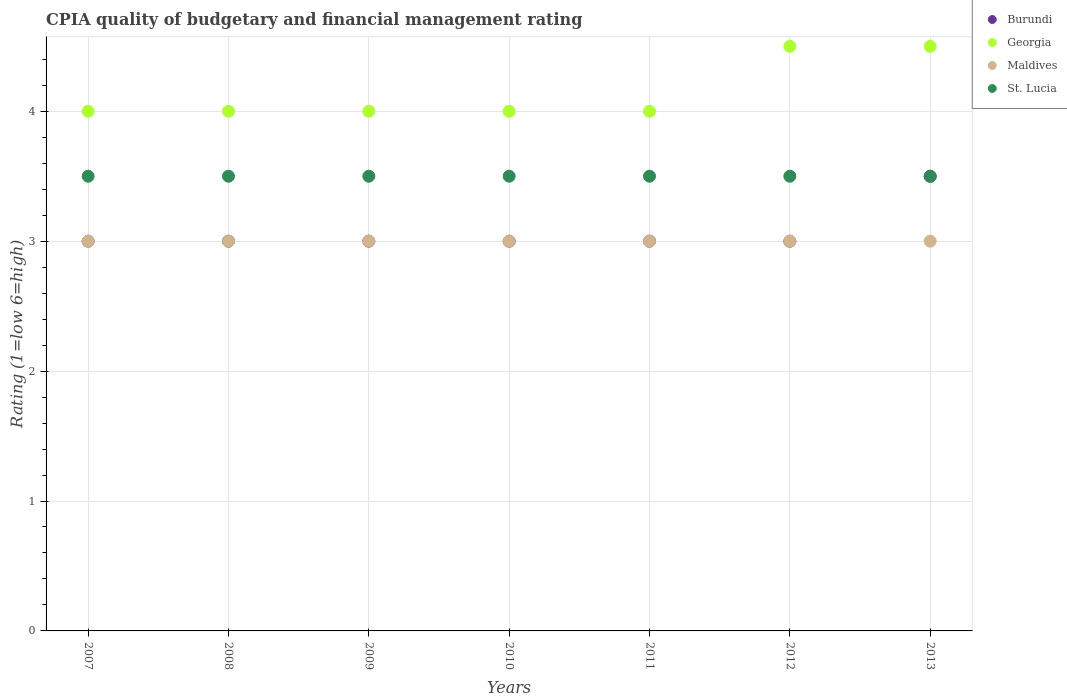Across all years, what is the minimum CPIA rating in Maldives?
Your answer should be compact. 3. In which year was the CPIA rating in St. Lucia maximum?
Ensure brevity in your answer.  2007. In which year was the CPIA rating in St. Lucia minimum?
Your response must be concise. 2007. What is the average CPIA rating in St. Lucia per year?
Offer a terse response. 3.5. In the year 2007, what is the difference between the CPIA rating in Maldives and CPIA rating in St. Lucia?
Offer a very short reply. -0.5. What is the ratio of the CPIA rating in Georgia in 2007 to that in 2013?
Make the answer very short. 0.89. In how many years, is the CPIA rating in Georgia greater than the average CPIA rating in Georgia taken over all years?
Your answer should be compact. 2. Is it the case that in every year, the sum of the CPIA rating in Burundi and CPIA rating in Maldives  is greater than the sum of CPIA rating in St. Lucia and CPIA rating in Georgia?
Your answer should be very brief. No. Is it the case that in every year, the sum of the CPIA rating in Georgia and CPIA rating in St. Lucia  is greater than the CPIA rating in Maldives?
Your response must be concise. Yes. Does the CPIA rating in Maldives monotonically increase over the years?
Provide a succinct answer. No. Is the CPIA rating in St. Lucia strictly greater than the CPIA rating in Georgia over the years?
Your answer should be compact. No. How many dotlines are there?
Provide a succinct answer. 4. How many years are there in the graph?
Your answer should be compact. 7. What is the difference between two consecutive major ticks on the Y-axis?
Give a very brief answer. 1. Are the values on the major ticks of Y-axis written in scientific E-notation?
Give a very brief answer. No. Does the graph contain grids?
Make the answer very short. Yes. Where does the legend appear in the graph?
Your answer should be very brief. Top right. What is the title of the graph?
Keep it short and to the point. CPIA quality of budgetary and financial management rating. What is the label or title of the X-axis?
Provide a succinct answer. Years. What is the Rating (1=low 6=high) in Burundi in 2007?
Your response must be concise. 3. What is the Rating (1=low 6=high) in Georgia in 2007?
Provide a succinct answer. 4. What is the Rating (1=low 6=high) in Maldives in 2007?
Offer a very short reply. 3. What is the Rating (1=low 6=high) in St. Lucia in 2007?
Your answer should be compact. 3.5. What is the Rating (1=low 6=high) in Georgia in 2008?
Offer a very short reply. 4. What is the Rating (1=low 6=high) of St. Lucia in 2008?
Provide a succinct answer. 3.5. What is the Rating (1=low 6=high) of Maldives in 2009?
Ensure brevity in your answer.  3. What is the Rating (1=low 6=high) of St. Lucia in 2009?
Ensure brevity in your answer.  3.5. What is the Rating (1=low 6=high) of Burundi in 2010?
Ensure brevity in your answer.  3. What is the Rating (1=low 6=high) in Georgia in 2010?
Offer a very short reply. 4. What is the Rating (1=low 6=high) in Georgia in 2011?
Provide a succinct answer. 4. What is the Rating (1=low 6=high) of Georgia in 2013?
Keep it short and to the point. 4.5. What is the Rating (1=low 6=high) of St. Lucia in 2013?
Your response must be concise. 3.5. Across all years, what is the maximum Rating (1=low 6=high) in Burundi?
Your answer should be very brief. 3.5. Across all years, what is the maximum Rating (1=low 6=high) in Georgia?
Ensure brevity in your answer.  4.5. Across all years, what is the maximum Rating (1=low 6=high) in St. Lucia?
Give a very brief answer. 3.5. Across all years, what is the minimum Rating (1=low 6=high) in Georgia?
Give a very brief answer. 4. Across all years, what is the minimum Rating (1=low 6=high) of Maldives?
Provide a succinct answer. 3. Across all years, what is the minimum Rating (1=low 6=high) in St. Lucia?
Offer a terse response. 3.5. What is the total Rating (1=low 6=high) of Maldives in the graph?
Your answer should be very brief. 21. What is the difference between the Rating (1=low 6=high) of Burundi in 2007 and that in 2008?
Your response must be concise. 0. What is the difference between the Rating (1=low 6=high) of St. Lucia in 2007 and that in 2008?
Provide a short and direct response. 0. What is the difference between the Rating (1=low 6=high) in Maldives in 2007 and that in 2009?
Your answer should be compact. 0. What is the difference between the Rating (1=low 6=high) in St. Lucia in 2007 and that in 2009?
Provide a short and direct response. 0. What is the difference between the Rating (1=low 6=high) of Burundi in 2007 and that in 2010?
Keep it short and to the point. 0. What is the difference between the Rating (1=low 6=high) of Georgia in 2007 and that in 2010?
Give a very brief answer. 0. What is the difference between the Rating (1=low 6=high) of St. Lucia in 2007 and that in 2010?
Keep it short and to the point. 0. What is the difference between the Rating (1=low 6=high) in Maldives in 2007 and that in 2011?
Keep it short and to the point. 0. What is the difference between the Rating (1=low 6=high) of St. Lucia in 2007 and that in 2011?
Provide a succinct answer. 0. What is the difference between the Rating (1=low 6=high) in Georgia in 2007 and that in 2012?
Ensure brevity in your answer.  -0.5. What is the difference between the Rating (1=low 6=high) in Maldives in 2007 and that in 2012?
Provide a short and direct response. 0. What is the difference between the Rating (1=low 6=high) of Burundi in 2007 and that in 2013?
Your answer should be compact. -0.5. What is the difference between the Rating (1=low 6=high) in St. Lucia in 2007 and that in 2013?
Offer a terse response. 0. What is the difference between the Rating (1=low 6=high) in Georgia in 2008 and that in 2009?
Make the answer very short. 0. What is the difference between the Rating (1=low 6=high) in Georgia in 2008 and that in 2010?
Your response must be concise. 0. What is the difference between the Rating (1=low 6=high) of St. Lucia in 2008 and that in 2010?
Keep it short and to the point. 0. What is the difference between the Rating (1=low 6=high) in Burundi in 2008 and that in 2011?
Offer a terse response. 0. What is the difference between the Rating (1=low 6=high) in Georgia in 2008 and that in 2011?
Your answer should be very brief. 0. What is the difference between the Rating (1=low 6=high) of Maldives in 2008 and that in 2012?
Provide a short and direct response. 0. What is the difference between the Rating (1=low 6=high) of Georgia in 2008 and that in 2013?
Provide a succinct answer. -0.5. What is the difference between the Rating (1=low 6=high) of Maldives in 2008 and that in 2013?
Offer a terse response. 0. What is the difference between the Rating (1=low 6=high) of St. Lucia in 2008 and that in 2013?
Keep it short and to the point. 0. What is the difference between the Rating (1=low 6=high) of St. Lucia in 2009 and that in 2010?
Provide a succinct answer. 0. What is the difference between the Rating (1=low 6=high) in Maldives in 2009 and that in 2011?
Provide a short and direct response. 0. What is the difference between the Rating (1=low 6=high) in St. Lucia in 2009 and that in 2011?
Keep it short and to the point. 0. What is the difference between the Rating (1=low 6=high) in Maldives in 2009 and that in 2013?
Give a very brief answer. 0. What is the difference between the Rating (1=low 6=high) of St. Lucia in 2009 and that in 2013?
Keep it short and to the point. 0. What is the difference between the Rating (1=low 6=high) of Burundi in 2010 and that in 2011?
Offer a terse response. 0. What is the difference between the Rating (1=low 6=high) in St. Lucia in 2010 and that in 2011?
Provide a succinct answer. 0. What is the difference between the Rating (1=low 6=high) of Georgia in 2010 and that in 2012?
Provide a succinct answer. -0.5. What is the difference between the Rating (1=low 6=high) of Maldives in 2010 and that in 2012?
Offer a very short reply. 0. What is the difference between the Rating (1=low 6=high) in St. Lucia in 2010 and that in 2012?
Offer a very short reply. 0. What is the difference between the Rating (1=low 6=high) in Burundi in 2010 and that in 2013?
Offer a terse response. -0.5. What is the difference between the Rating (1=low 6=high) of Georgia in 2010 and that in 2013?
Offer a very short reply. -0.5. What is the difference between the Rating (1=low 6=high) in Maldives in 2010 and that in 2013?
Your answer should be compact. 0. What is the difference between the Rating (1=low 6=high) of Maldives in 2011 and that in 2012?
Give a very brief answer. 0. What is the difference between the Rating (1=low 6=high) of Georgia in 2012 and that in 2013?
Give a very brief answer. 0. What is the difference between the Rating (1=low 6=high) of Burundi in 2007 and the Rating (1=low 6=high) of Georgia in 2008?
Provide a succinct answer. -1. What is the difference between the Rating (1=low 6=high) of Burundi in 2007 and the Rating (1=low 6=high) of Maldives in 2008?
Provide a short and direct response. 0. What is the difference between the Rating (1=low 6=high) in Burundi in 2007 and the Rating (1=low 6=high) in St. Lucia in 2008?
Offer a terse response. -0.5. What is the difference between the Rating (1=low 6=high) in Georgia in 2007 and the Rating (1=low 6=high) in St. Lucia in 2008?
Keep it short and to the point. 0.5. What is the difference between the Rating (1=low 6=high) in Maldives in 2007 and the Rating (1=low 6=high) in St. Lucia in 2008?
Your response must be concise. -0.5. What is the difference between the Rating (1=low 6=high) of Burundi in 2007 and the Rating (1=low 6=high) of Georgia in 2009?
Your response must be concise. -1. What is the difference between the Rating (1=low 6=high) in Georgia in 2007 and the Rating (1=low 6=high) in Maldives in 2009?
Provide a succinct answer. 1. What is the difference between the Rating (1=low 6=high) of Maldives in 2007 and the Rating (1=low 6=high) of St. Lucia in 2009?
Make the answer very short. -0.5. What is the difference between the Rating (1=low 6=high) in Georgia in 2007 and the Rating (1=low 6=high) in Maldives in 2010?
Make the answer very short. 1. What is the difference between the Rating (1=low 6=high) in Georgia in 2007 and the Rating (1=low 6=high) in St. Lucia in 2010?
Offer a very short reply. 0.5. What is the difference between the Rating (1=low 6=high) of Burundi in 2007 and the Rating (1=low 6=high) of Maldives in 2011?
Offer a terse response. 0. What is the difference between the Rating (1=low 6=high) of Georgia in 2007 and the Rating (1=low 6=high) of St. Lucia in 2011?
Give a very brief answer. 0.5. What is the difference between the Rating (1=low 6=high) in Maldives in 2007 and the Rating (1=low 6=high) in St. Lucia in 2011?
Provide a short and direct response. -0.5. What is the difference between the Rating (1=low 6=high) of Burundi in 2007 and the Rating (1=low 6=high) of Georgia in 2012?
Provide a short and direct response. -1.5. What is the difference between the Rating (1=low 6=high) of Georgia in 2007 and the Rating (1=low 6=high) of St. Lucia in 2012?
Give a very brief answer. 0.5. What is the difference between the Rating (1=low 6=high) in Burundi in 2007 and the Rating (1=low 6=high) in Georgia in 2013?
Your response must be concise. -1.5. What is the difference between the Rating (1=low 6=high) of Burundi in 2007 and the Rating (1=low 6=high) of St. Lucia in 2013?
Give a very brief answer. -0.5. What is the difference between the Rating (1=low 6=high) of Georgia in 2007 and the Rating (1=low 6=high) of St. Lucia in 2013?
Ensure brevity in your answer.  0.5. What is the difference between the Rating (1=low 6=high) in Burundi in 2008 and the Rating (1=low 6=high) in Georgia in 2009?
Offer a terse response. -1. What is the difference between the Rating (1=low 6=high) of Burundi in 2008 and the Rating (1=low 6=high) of St. Lucia in 2009?
Keep it short and to the point. -0.5. What is the difference between the Rating (1=low 6=high) of Georgia in 2008 and the Rating (1=low 6=high) of Maldives in 2009?
Give a very brief answer. 1. What is the difference between the Rating (1=low 6=high) of Maldives in 2008 and the Rating (1=low 6=high) of St. Lucia in 2009?
Your answer should be very brief. -0.5. What is the difference between the Rating (1=low 6=high) of Burundi in 2008 and the Rating (1=low 6=high) of Maldives in 2010?
Provide a short and direct response. 0. What is the difference between the Rating (1=low 6=high) in Burundi in 2008 and the Rating (1=low 6=high) in St. Lucia in 2010?
Keep it short and to the point. -0.5. What is the difference between the Rating (1=low 6=high) of Georgia in 2008 and the Rating (1=low 6=high) of Maldives in 2010?
Give a very brief answer. 1. What is the difference between the Rating (1=low 6=high) of Maldives in 2008 and the Rating (1=low 6=high) of St. Lucia in 2010?
Make the answer very short. -0.5. What is the difference between the Rating (1=low 6=high) in Burundi in 2008 and the Rating (1=low 6=high) in Georgia in 2011?
Give a very brief answer. -1. What is the difference between the Rating (1=low 6=high) of Burundi in 2008 and the Rating (1=low 6=high) of St. Lucia in 2011?
Offer a very short reply. -0.5. What is the difference between the Rating (1=low 6=high) in Georgia in 2008 and the Rating (1=low 6=high) in Maldives in 2011?
Provide a short and direct response. 1. What is the difference between the Rating (1=low 6=high) in Georgia in 2008 and the Rating (1=low 6=high) in St. Lucia in 2011?
Keep it short and to the point. 0.5. What is the difference between the Rating (1=low 6=high) of Maldives in 2008 and the Rating (1=low 6=high) of St. Lucia in 2011?
Provide a succinct answer. -0.5. What is the difference between the Rating (1=low 6=high) of Georgia in 2008 and the Rating (1=low 6=high) of Maldives in 2012?
Give a very brief answer. 1. What is the difference between the Rating (1=low 6=high) of Georgia in 2008 and the Rating (1=low 6=high) of St. Lucia in 2012?
Provide a succinct answer. 0.5. What is the difference between the Rating (1=low 6=high) in Maldives in 2008 and the Rating (1=low 6=high) in St. Lucia in 2012?
Your answer should be very brief. -0.5. What is the difference between the Rating (1=low 6=high) of Maldives in 2008 and the Rating (1=low 6=high) of St. Lucia in 2013?
Your answer should be very brief. -0.5. What is the difference between the Rating (1=low 6=high) of Burundi in 2009 and the Rating (1=low 6=high) of Maldives in 2010?
Provide a succinct answer. 0. What is the difference between the Rating (1=low 6=high) of Georgia in 2009 and the Rating (1=low 6=high) of Maldives in 2010?
Offer a very short reply. 1. What is the difference between the Rating (1=low 6=high) of Georgia in 2009 and the Rating (1=low 6=high) of St. Lucia in 2010?
Keep it short and to the point. 0.5. What is the difference between the Rating (1=low 6=high) of Maldives in 2009 and the Rating (1=low 6=high) of St. Lucia in 2010?
Provide a succinct answer. -0.5. What is the difference between the Rating (1=low 6=high) of Burundi in 2009 and the Rating (1=low 6=high) of Georgia in 2011?
Your answer should be very brief. -1. What is the difference between the Rating (1=low 6=high) of Burundi in 2009 and the Rating (1=low 6=high) of Maldives in 2011?
Your response must be concise. 0. What is the difference between the Rating (1=low 6=high) in Georgia in 2009 and the Rating (1=low 6=high) in St. Lucia in 2011?
Provide a succinct answer. 0.5. What is the difference between the Rating (1=low 6=high) of Maldives in 2009 and the Rating (1=low 6=high) of St. Lucia in 2011?
Your response must be concise. -0.5. What is the difference between the Rating (1=low 6=high) of Burundi in 2009 and the Rating (1=low 6=high) of Maldives in 2012?
Make the answer very short. 0. What is the difference between the Rating (1=low 6=high) of Georgia in 2009 and the Rating (1=low 6=high) of St. Lucia in 2012?
Make the answer very short. 0.5. What is the difference between the Rating (1=low 6=high) of Burundi in 2009 and the Rating (1=low 6=high) of St. Lucia in 2013?
Provide a short and direct response. -0.5. What is the difference between the Rating (1=low 6=high) of Georgia in 2009 and the Rating (1=low 6=high) of Maldives in 2013?
Your response must be concise. 1. What is the difference between the Rating (1=low 6=high) in Georgia in 2009 and the Rating (1=low 6=high) in St. Lucia in 2013?
Ensure brevity in your answer.  0.5. What is the difference between the Rating (1=low 6=high) in Burundi in 2010 and the Rating (1=low 6=high) in Georgia in 2011?
Your response must be concise. -1. What is the difference between the Rating (1=low 6=high) of Burundi in 2010 and the Rating (1=low 6=high) of Maldives in 2011?
Your response must be concise. 0. What is the difference between the Rating (1=low 6=high) of Burundi in 2010 and the Rating (1=low 6=high) of St. Lucia in 2011?
Offer a very short reply. -0.5. What is the difference between the Rating (1=low 6=high) of Georgia in 2010 and the Rating (1=low 6=high) of Maldives in 2011?
Your answer should be very brief. 1. What is the difference between the Rating (1=low 6=high) of Maldives in 2010 and the Rating (1=low 6=high) of St. Lucia in 2011?
Ensure brevity in your answer.  -0.5. What is the difference between the Rating (1=low 6=high) of Burundi in 2010 and the Rating (1=low 6=high) of Georgia in 2012?
Ensure brevity in your answer.  -1.5. What is the difference between the Rating (1=low 6=high) in Burundi in 2010 and the Rating (1=low 6=high) in Maldives in 2012?
Your response must be concise. 0. What is the difference between the Rating (1=low 6=high) of Burundi in 2010 and the Rating (1=low 6=high) of St. Lucia in 2012?
Your response must be concise. -0.5. What is the difference between the Rating (1=low 6=high) in Georgia in 2010 and the Rating (1=low 6=high) in Maldives in 2012?
Ensure brevity in your answer.  1. What is the difference between the Rating (1=low 6=high) of Georgia in 2010 and the Rating (1=low 6=high) of St. Lucia in 2012?
Keep it short and to the point. 0.5. What is the difference between the Rating (1=low 6=high) of Maldives in 2010 and the Rating (1=low 6=high) of St. Lucia in 2012?
Offer a very short reply. -0.5. What is the difference between the Rating (1=low 6=high) of Burundi in 2010 and the Rating (1=low 6=high) of St. Lucia in 2013?
Keep it short and to the point. -0.5. What is the difference between the Rating (1=low 6=high) of Georgia in 2010 and the Rating (1=low 6=high) of Maldives in 2013?
Your answer should be very brief. 1. What is the difference between the Rating (1=low 6=high) of Burundi in 2011 and the Rating (1=low 6=high) of Maldives in 2012?
Provide a short and direct response. 0. What is the difference between the Rating (1=low 6=high) of Burundi in 2011 and the Rating (1=low 6=high) of St. Lucia in 2012?
Provide a succinct answer. -0.5. What is the difference between the Rating (1=low 6=high) of Burundi in 2011 and the Rating (1=low 6=high) of Maldives in 2013?
Make the answer very short. 0. What is the difference between the Rating (1=low 6=high) in Burundi in 2011 and the Rating (1=low 6=high) in St. Lucia in 2013?
Your response must be concise. -0.5. What is the difference between the Rating (1=low 6=high) of Georgia in 2011 and the Rating (1=low 6=high) of Maldives in 2013?
Offer a terse response. 1. What is the difference between the Rating (1=low 6=high) of Maldives in 2011 and the Rating (1=low 6=high) of St. Lucia in 2013?
Give a very brief answer. -0.5. What is the difference between the Rating (1=low 6=high) of Burundi in 2012 and the Rating (1=low 6=high) of Georgia in 2013?
Keep it short and to the point. -1.5. What is the difference between the Rating (1=low 6=high) in Georgia in 2012 and the Rating (1=low 6=high) in Maldives in 2013?
Provide a succinct answer. 1.5. What is the average Rating (1=low 6=high) of Burundi per year?
Your response must be concise. 3.07. What is the average Rating (1=low 6=high) in Georgia per year?
Give a very brief answer. 4.14. What is the average Rating (1=low 6=high) in St. Lucia per year?
Provide a succinct answer. 3.5. In the year 2007, what is the difference between the Rating (1=low 6=high) in Burundi and Rating (1=low 6=high) in Georgia?
Give a very brief answer. -1. In the year 2007, what is the difference between the Rating (1=low 6=high) of Burundi and Rating (1=low 6=high) of Maldives?
Your answer should be compact. 0. In the year 2007, what is the difference between the Rating (1=low 6=high) of Maldives and Rating (1=low 6=high) of St. Lucia?
Provide a succinct answer. -0.5. In the year 2008, what is the difference between the Rating (1=low 6=high) in Burundi and Rating (1=low 6=high) in Georgia?
Your answer should be very brief. -1. In the year 2008, what is the difference between the Rating (1=low 6=high) in Burundi and Rating (1=low 6=high) in Maldives?
Your answer should be very brief. 0. In the year 2008, what is the difference between the Rating (1=low 6=high) in Burundi and Rating (1=low 6=high) in St. Lucia?
Offer a very short reply. -0.5. In the year 2008, what is the difference between the Rating (1=low 6=high) of Georgia and Rating (1=low 6=high) of Maldives?
Make the answer very short. 1. In the year 2008, what is the difference between the Rating (1=low 6=high) of Maldives and Rating (1=low 6=high) of St. Lucia?
Your response must be concise. -0.5. In the year 2009, what is the difference between the Rating (1=low 6=high) in Burundi and Rating (1=low 6=high) in Maldives?
Make the answer very short. 0. In the year 2009, what is the difference between the Rating (1=low 6=high) of Burundi and Rating (1=low 6=high) of St. Lucia?
Your response must be concise. -0.5. In the year 2009, what is the difference between the Rating (1=low 6=high) in Georgia and Rating (1=low 6=high) in St. Lucia?
Offer a terse response. 0.5. In the year 2010, what is the difference between the Rating (1=low 6=high) in Burundi and Rating (1=low 6=high) in St. Lucia?
Give a very brief answer. -0.5. In the year 2010, what is the difference between the Rating (1=low 6=high) in Georgia and Rating (1=low 6=high) in St. Lucia?
Offer a very short reply. 0.5. In the year 2010, what is the difference between the Rating (1=low 6=high) of Maldives and Rating (1=low 6=high) of St. Lucia?
Your answer should be very brief. -0.5. In the year 2011, what is the difference between the Rating (1=low 6=high) in Burundi and Rating (1=low 6=high) in Georgia?
Ensure brevity in your answer.  -1. In the year 2012, what is the difference between the Rating (1=low 6=high) in Georgia and Rating (1=low 6=high) in Maldives?
Give a very brief answer. 1.5. In the year 2013, what is the difference between the Rating (1=low 6=high) of Burundi and Rating (1=low 6=high) of Georgia?
Your answer should be compact. -1. In the year 2013, what is the difference between the Rating (1=low 6=high) in Burundi and Rating (1=low 6=high) in St. Lucia?
Your answer should be compact. 0. In the year 2013, what is the difference between the Rating (1=low 6=high) of Georgia and Rating (1=low 6=high) of St. Lucia?
Make the answer very short. 1. What is the ratio of the Rating (1=low 6=high) of Maldives in 2007 to that in 2008?
Provide a short and direct response. 1. What is the ratio of the Rating (1=low 6=high) in St. Lucia in 2007 to that in 2008?
Offer a terse response. 1. What is the ratio of the Rating (1=low 6=high) of Georgia in 2007 to that in 2009?
Ensure brevity in your answer.  1. What is the ratio of the Rating (1=low 6=high) of Maldives in 2007 to that in 2009?
Ensure brevity in your answer.  1. What is the ratio of the Rating (1=low 6=high) of St. Lucia in 2007 to that in 2009?
Offer a very short reply. 1. What is the ratio of the Rating (1=low 6=high) in Burundi in 2007 to that in 2010?
Offer a terse response. 1. What is the ratio of the Rating (1=low 6=high) of St. Lucia in 2007 to that in 2010?
Give a very brief answer. 1. What is the ratio of the Rating (1=low 6=high) of Georgia in 2007 to that in 2011?
Make the answer very short. 1. What is the ratio of the Rating (1=low 6=high) of Maldives in 2007 to that in 2011?
Keep it short and to the point. 1. What is the ratio of the Rating (1=low 6=high) in St. Lucia in 2007 to that in 2011?
Provide a short and direct response. 1. What is the ratio of the Rating (1=low 6=high) of St. Lucia in 2007 to that in 2012?
Keep it short and to the point. 1. What is the ratio of the Rating (1=low 6=high) in Georgia in 2007 to that in 2013?
Offer a terse response. 0.89. What is the ratio of the Rating (1=low 6=high) in Maldives in 2007 to that in 2013?
Your answer should be compact. 1. What is the ratio of the Rating (1=low 6=high) of Georgia in 2008 to that in 2009?
Offer a very short reply. 1. What is the ratio of the Rating (1=low 6=high) in Maldives in 2008 to that in 2009?
Give a very brief answer. 1. What is the ratio of the Rating (1=low 6=high) of St. Lucia in 2008 to that in 2010?
Provide a succinct answer. 1. What is the ratio of the Rating (1=low 6=high) of Burundi in 2008 to that in 2011?
Provide a short and direct response. 1. What is the ratio of the Rating (1=low 6=high) in Georgia in 2008 to that in 2012?
Provide a short and direct response. 0.89. What is the ratio of the Rating (1=low 6=high) in Maldives in 2008 to that in 2012?
Provide a short and direct response. 1. What is the ratio of the Rating (1=low 6=high) of St. Lucia in 2008 to that in 2012?
Provide a short and direct response. 1. What is the ratio of the Rating (1=low 6=high) of Burundi in 2008 to that in 2013?
Your answer should be very brief. 0.86. What is the ratio of the Rating (1=low 6=high) in Georgia in 2008 to that in 2013?
Offer a very short reply. 0.89. What is the ratio of the Rating (1=low 6=high) of St. Lucia in 2008 to that in 2013?
Provide a succinct answer. 1. What is the ratio of the Rating (1=low 6=high) of Georgia in 2009 to that in 2010?
Make the answer very short. 1. What is the ratio of the Rating (1=low 6=high) in Maldives in 2009 to that in 2010?
Your response must be concise. 1. What is the ratio of the Rating (1=low 6=high) in Burundi in 2009 to that in 2011?
Your answer should be compact. 1. What is the ratio of the Rating (1=low 6=high) in Maldives in 2009 to that in 2011?
Keep it short and to the point. 1. What is the ratio of the Rating (1=low 6=high) of St. Lucia in 2009 to that in 2011?
Offer a terse response. 1. What is the ratio of the Rating (1=low 6=high) of Burundi in 2009 to that in 2012?
Make the answer very short. 1. What is the ratio of the Rating (1=low 6=high) of Georgia in 2009 to that in 2012?
Make the answer very short. 0.89. What is the ratio of the Rating (1=low 6=high) of Maldives in 2009 to that in 2012?
Give a very brief answer. 1. What is the ratio of the Rating (1=low 6=high) of St. Lucia in 2009 to that in 2012?
Keep it short and to the point. 1. What is the ratio of the Rating (1=low 6=high) in St. Lucia in 2009 to that in 2013?
Keep it short and to the point. 1. What is the ratio of the Rating (1=low 6=high) of Burundi in 2010 to that in 2011?
Give a very brief answer. 1. What is the ratio of the Rating (1=low 6=high) in Georgia in 2010 to that in 2011?
Ensure brevity in your answer.  1. What is the ratio of the Rating (1=low 6=high) of Maldives in 2010 to that in 2011?
Your response must be concise. 1. What is the ratio of the Rating (1=low 6=high) of St. Lucia in 2010 to that in 2011?
Your answer should be compact. 1. What is the ratio of the Rating (1=low 6=high) of Burundi in 2010 to that in 2012?
Ensure brevity in your answer.  1. What is the ratio of the Rating (1=low 6=high) of Georgia in 2010 to that in 2012?
Offer a terse response. 0.89. What is the ratio of the Rating (1=low 6=high) in Maldives in 2010 to that in 2012?
Keep it short and to the point. 1. What is the ratio of the Rating (1=low 6=high) in St. Lucia in 2010 to that in 2012?
Offer a terse response. 1. What is the ratio of the Rating (1=low 6=high) in Burundi in 2010 to that in 2013?
Provide a succinct answer. 0.86. What is the ratio of the Rating (1=low 6=high) in Maldives in 2010 to that in 2013?
Your answer should be very brief. 1. What is the ratio of the Rating (1=low 6=high) in St. Lucia in 2010 to that in 2013?
Provide a short and direct response. 1. What is the ratio of the Rating (1=low 6=high) of St. Lucia in 2011 to that in 2012?
Ensure brevity in your answer.  1. What is the ratio of the Rating (1=low 6=high) of Georgia in 2011 to that in 2013?
Provide a short and direct response. 0.89. What is the ratio of the Rating (1=low 6=high) of Maldives in 2011 to that in 2013?
Give a very brief answer. 1. What is the ratio of the Rating (1=low 6=high) of Georgia in 2012 to that in 2013?
Offer a very short reply. 1. What is the ratio of the Rating (1=low 6=high) of Maldives in 2012 to that in 2013?
Provide a short and direct response. 1. What is the difference between the highest and the second highest Rating (1=low 6=high) of Burundi?
Your answer should be compact. 0.5. What is the difference between the highest and the second highest Rating (1=low 6=high) in Georgia?
Give a very brief answer. 0. What is the difference between the highest and the second highest Rating (1=low 6=high) of Maldives?
Your answer should be very brief. 0. What is the difference between the highest and the lowest Rating (1=low 6=high) in Maldives?
Your response must be concise. 0. 